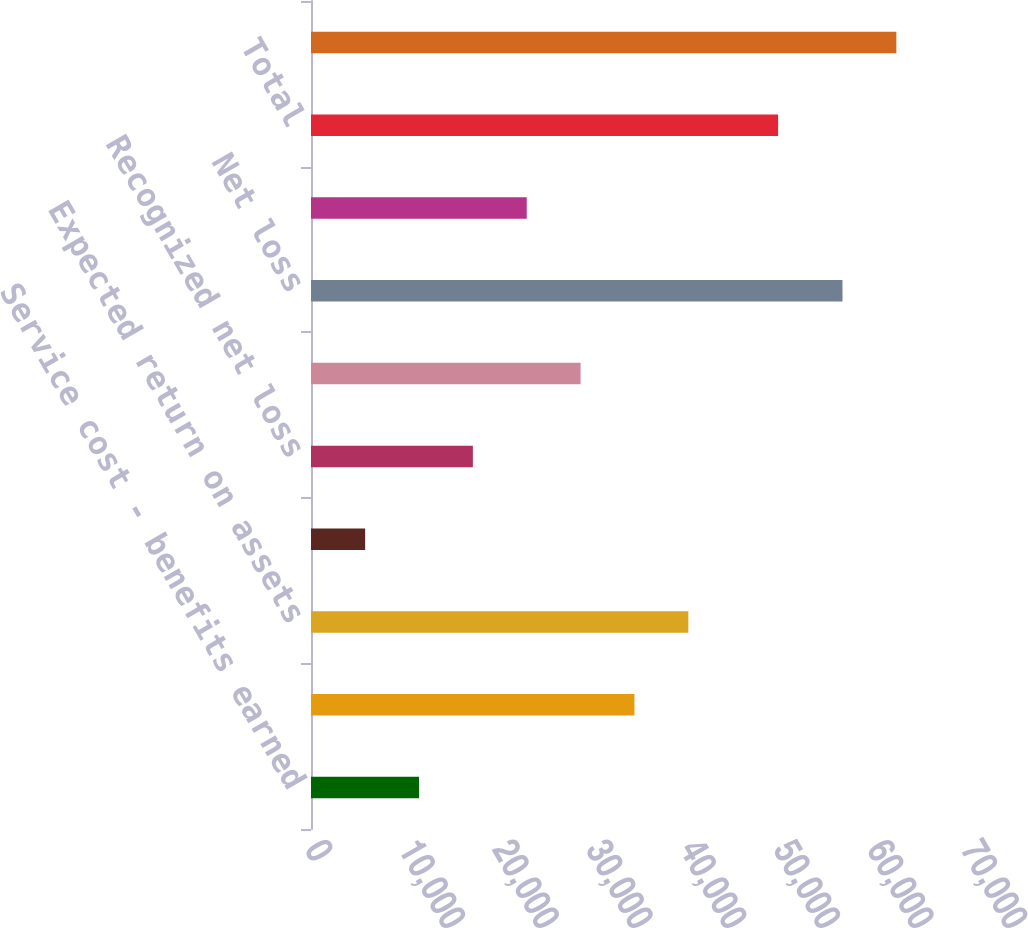<chart> <loc_0><loc_0><loc_500><loc_500><bar_chart><fcel>Service cost - benefits earned<fcel>Interest cost on projected<fcel>Expected return on assets<fcel>Amortization of prior service<fcel>Recognized net loss<fcel>Net pension cost<fcel>Net loss<fcel>Amortization of net loss<fcel>Total<fcel>Total recognized as net<nl><fcel>11525.4<fcel>34516.2<fcel>40263.9<fcel>5777.7<fcel>17273.1<fcel>28768.5<fcel>56714<fcel>23020.8<fcel>49845<fcel>62461.7<nl></chart> 